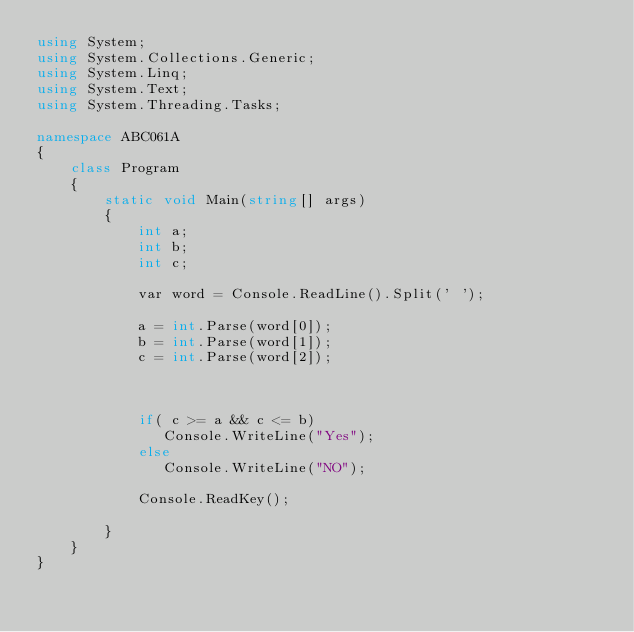Convert code to text. <code><loc_0><loc_0><loc_500><loc_500><_C#_>using System;
using System.Collections.Generic;
using System.Linq;
using System.Text;
using System.Threading.Tasks;

namespace ABC061A
{
    class Program
    {
        static void Main(string[] args)
        {
            int a;
            int b;
            int c;

            var word = Console.ReadLine().Split(' ');

            a = int.Parse(word[0]);
            b = int.Parse(word[1]);
            c = int.Parse(word[2]);
          


            if( c >= a && c <= b)
               Console.WriteLine("Yes");
            else 
               Console.WriteLine("NO");

            Console.ReadKey();

        }
    }
}
</code> 